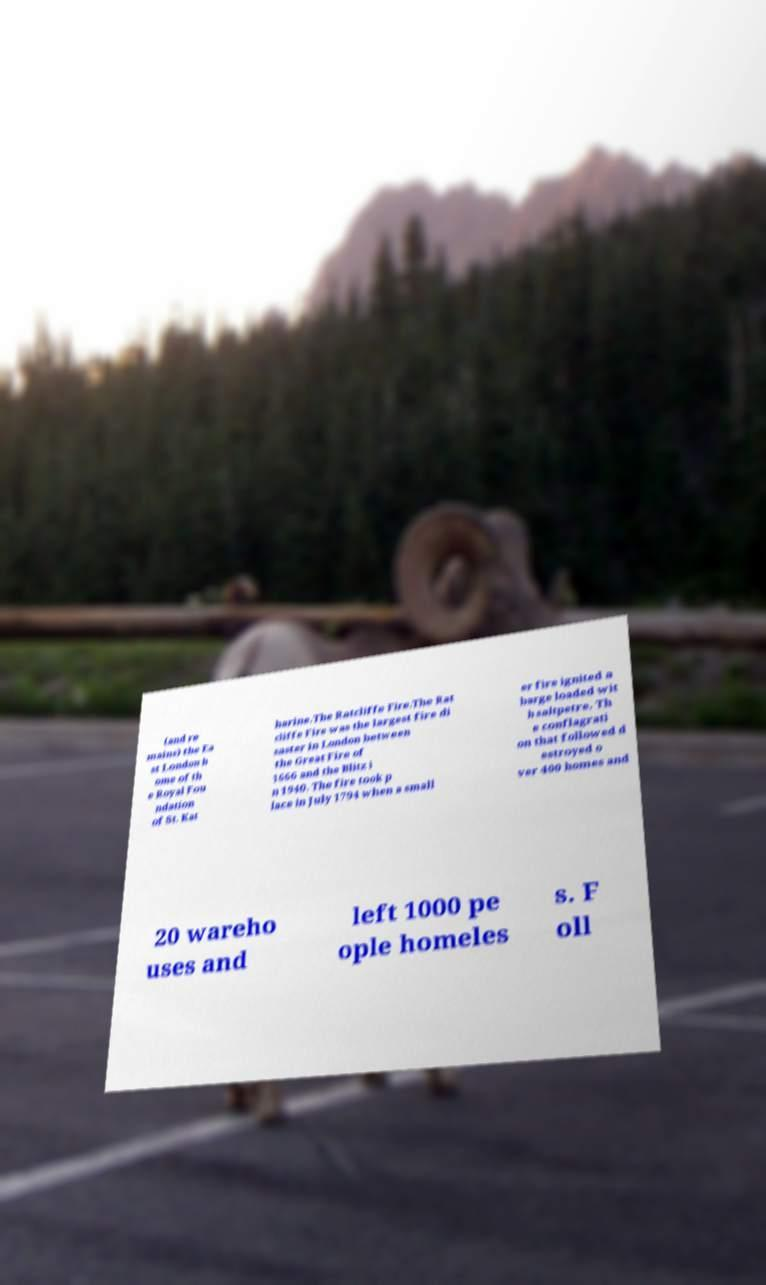What messages or text are displayed in this image? I need them in a readable, typed format. (and re mains) the Ea st London h ome of th e Royal Fou ndation of St. Kat harine.The Ratcliffe Fire.The Rat cliffe Fire was the largest fire di saster in London between the Great Fire of 1666 and the Blitz i n 1940. The fire took p lace in July 1794 when a small er fire ignited a barge loaded wit h saltpetre. Th e conflagrati on that followed d estroyed o ver 400 homes and 20 wareho uses and left 1000 pe ople homeles s. F oll 